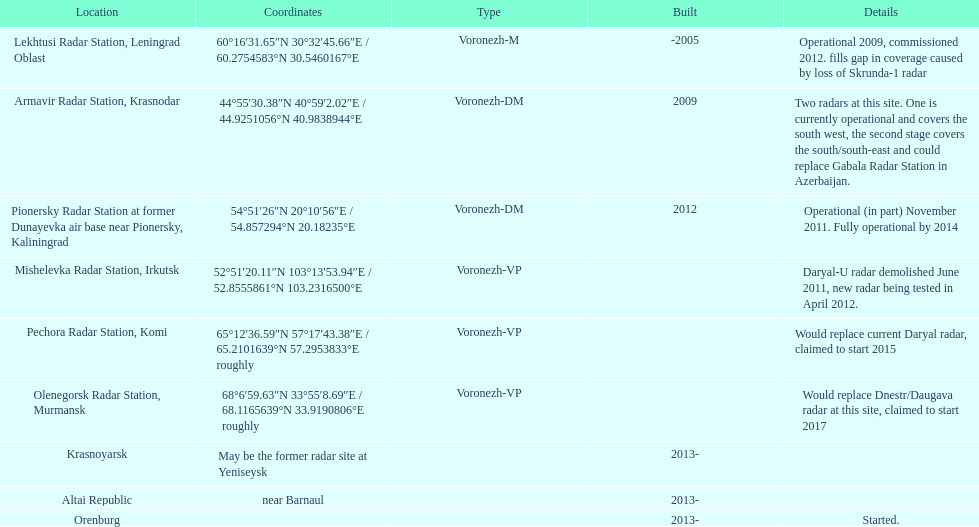Which site possesses the greatest quantity of radars? Armavir Radar Station, Krasnodar. 